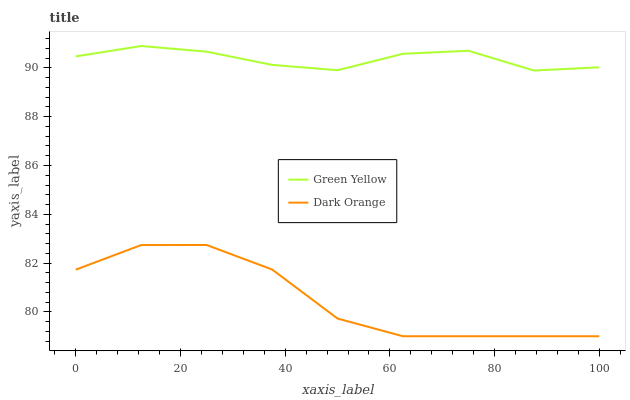Does Green Yellow have the minimum area under the curve?
Answer yes or no. No. Is Green Yellow the roughest?
Answer yes or no. No. Does Green Yellow have the lowest value?
Answer yes or no. No. Is Dark Orange less than Green Yellow?
Answer yes or no. Yes. Is Green Yellow greater than Dark Orange?
Answer yes or no. Yes. Does Dark Orange intersect Green Yellow?
Answer yes or no. No. 